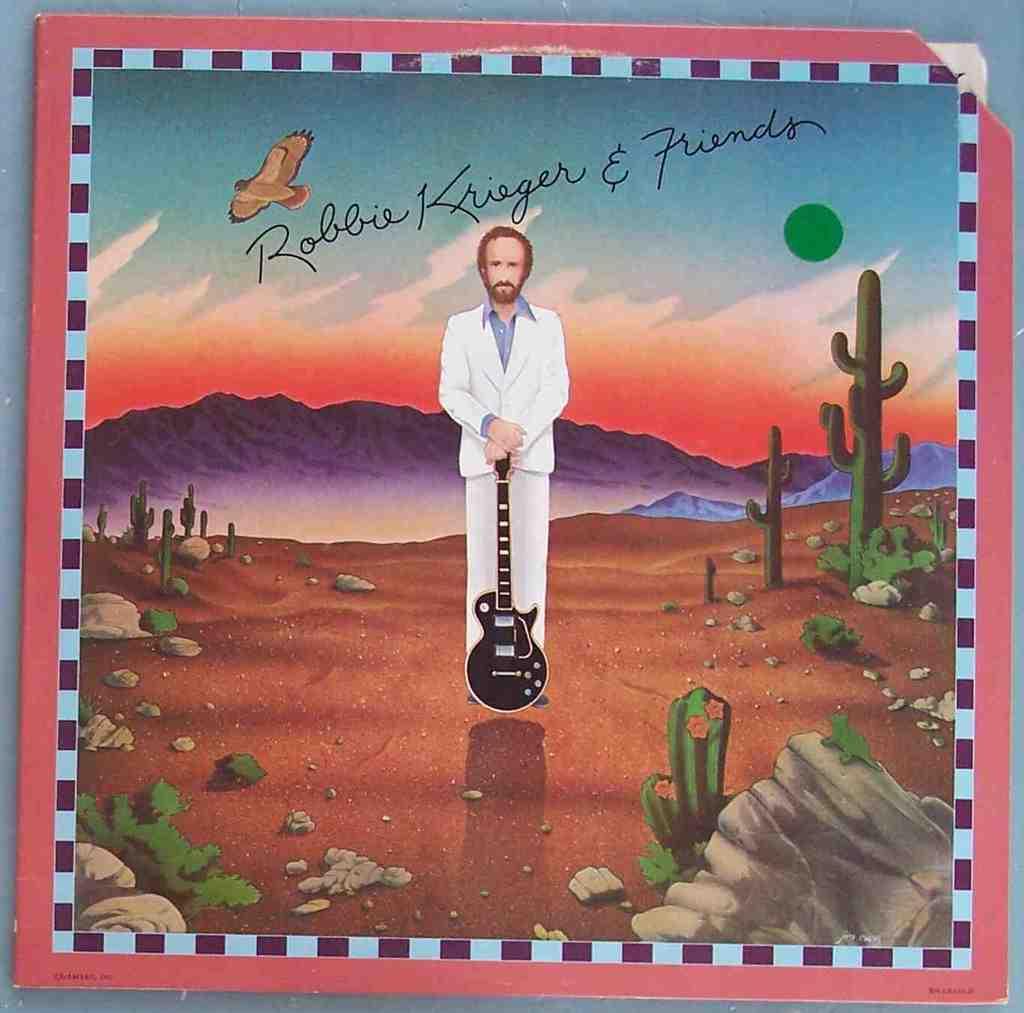Who is this?
Your answer should be very brief. Robbie krieger. What is the name of the artist in this band?
Your answer should be very brief. Robbie krieger. 